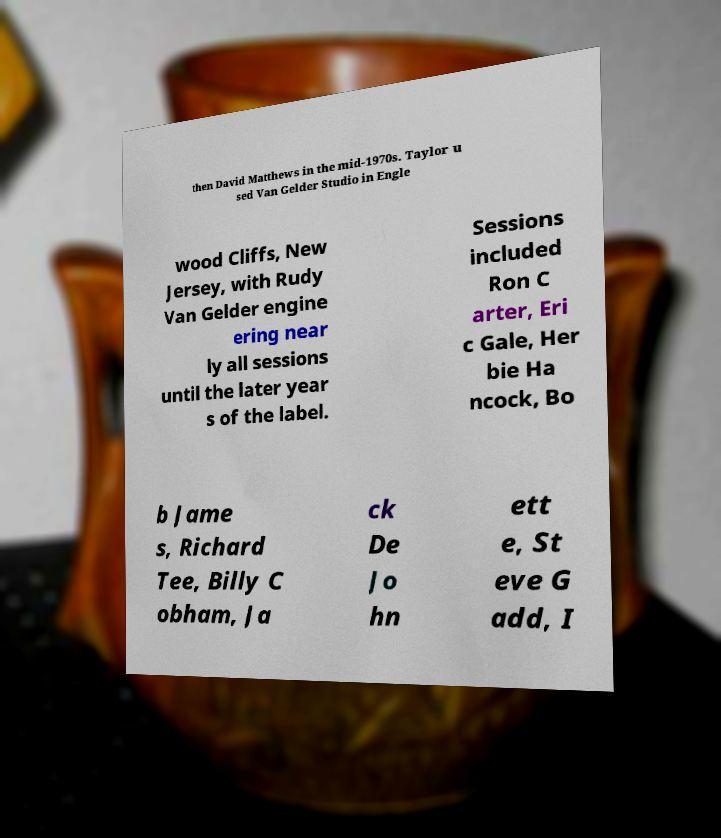There's text embedded in this image that I need extracted. Can you transcribe it verbatim? then David Matthews in the mid-1970s. Taylor u sed Van Gelder Studio in Engle wood Cliffs, New Jersey, with Rudy Van Gelder engine ering near ly all sessions until the later year s of the label. Sessions included Ron C arter, Eri c Gale, Her bie Ha ncock, Bo b Jame s, Richard Tee, Billy C obham, Ja ck De Jo hn ett e, St eve G add, I 